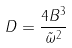Convert formula to latex. <formula><loc_0><loc_0><loc_500><loc_500>D = \frac { 4 B ^ { 3 } } { \tilde { \omega } ^ { 2 } }</formula> 